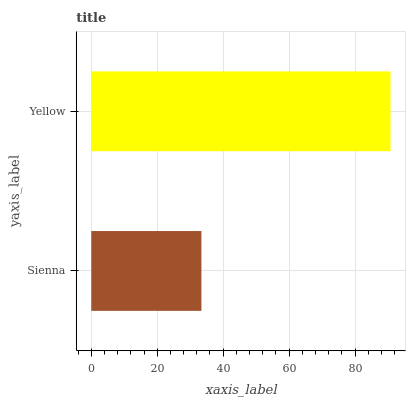Is Sienna the minimum?
Answer yes or no. Yes. Is Yellow the maximum?
Answer yes or no. Yes. Is Yellow the minimum?
Answer yes or no. No. Is Yellow greater than Sienna?
Answer yes or no. Yes. Is Sienna less than Yellow?
Answer yes or no. Yes. Is Sienna greater than Yellow?
Answer yes or no. No. Is Yellow less than Sienna?
Answer yes or no. No. Is Yellow the high median?
Answer yes or no. Yes. Is Sienna the low median?
Answer yes or no. Yes. Is Sienna the high median?
Answer yes or no. No. Is Yellow the low median?
Answer yes or no. No. 